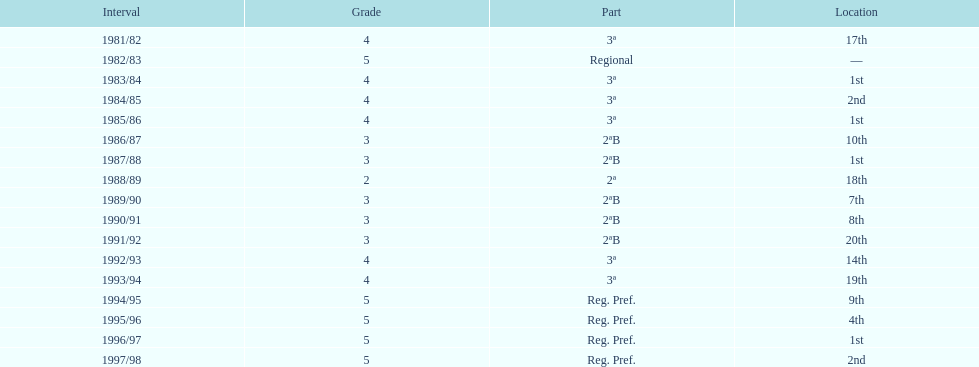Which tier was ud alzira a part of the least? 2. 